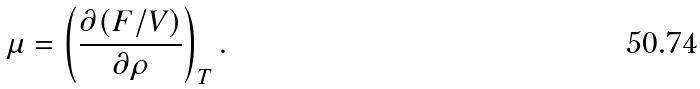<formula> <loc_0><loc_0><loc_500><loc_500>\mu = \left ( \frac { \partial ( F / V ) } { \partial \rho } \right ) _ { T } .</formula> 